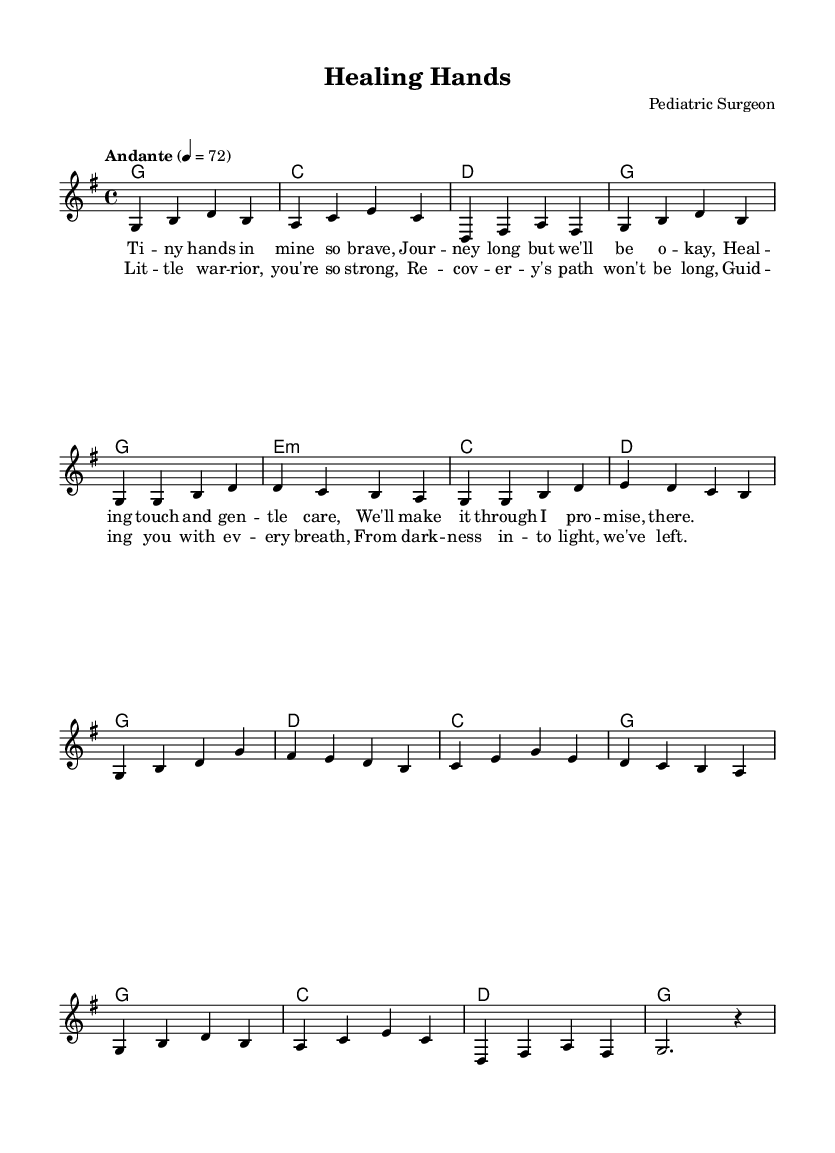What is the key signature of this music? The key signature shown at the beginning of the score indicates G major, which has one sharp. This can be identified by looking at the key signature symbol adjacent to the clef.
Answer: G major What is the time signature of this piece? The time signature, displayed in the beginning portion of the score, is 4/4. This indicates that each measure contains four beats, and each beat is a quarter note.
Answer: 4/4 What is the tempo marking given in this sheet music? The tempo marking at the start indicates "Andante," which signifies a moderately slow tempo. This is often reflected in the performance instructions at the beginning of the score.
Answer: Andante How many measures are in the verse section? By counting the measures laid out in the verse portion of the score, we see there are four measures total, as indicated by the notation ending before the chorus section begins.
Answer: 4 What type of musical piece is "Healing Hands"? The structure guidelines, lyrical themes, and instrumentation suggest that this is a ballad, as it focuses on emotional storytelling and a gentle melodic flow typically found in ballads.
Answer: Ballad What is the highest note in the melody? The highest note in the melody can be determined by scanning through the notes in the melody section and identifying that the note 'd' appears multiple times but is high in range, while 'g' marks the leading pitch. The highest appearing note is actually 'g' based on the relative measure of notes within the piece.
Answer: g How many chords are used in the chorus? The chords outlined in the chorus indicate four total different harmonic structures, as seen in the chord symbols aligned with the lyrical phrases of the chorus, confirming four distinct harmonic movements.
Answer: 4 